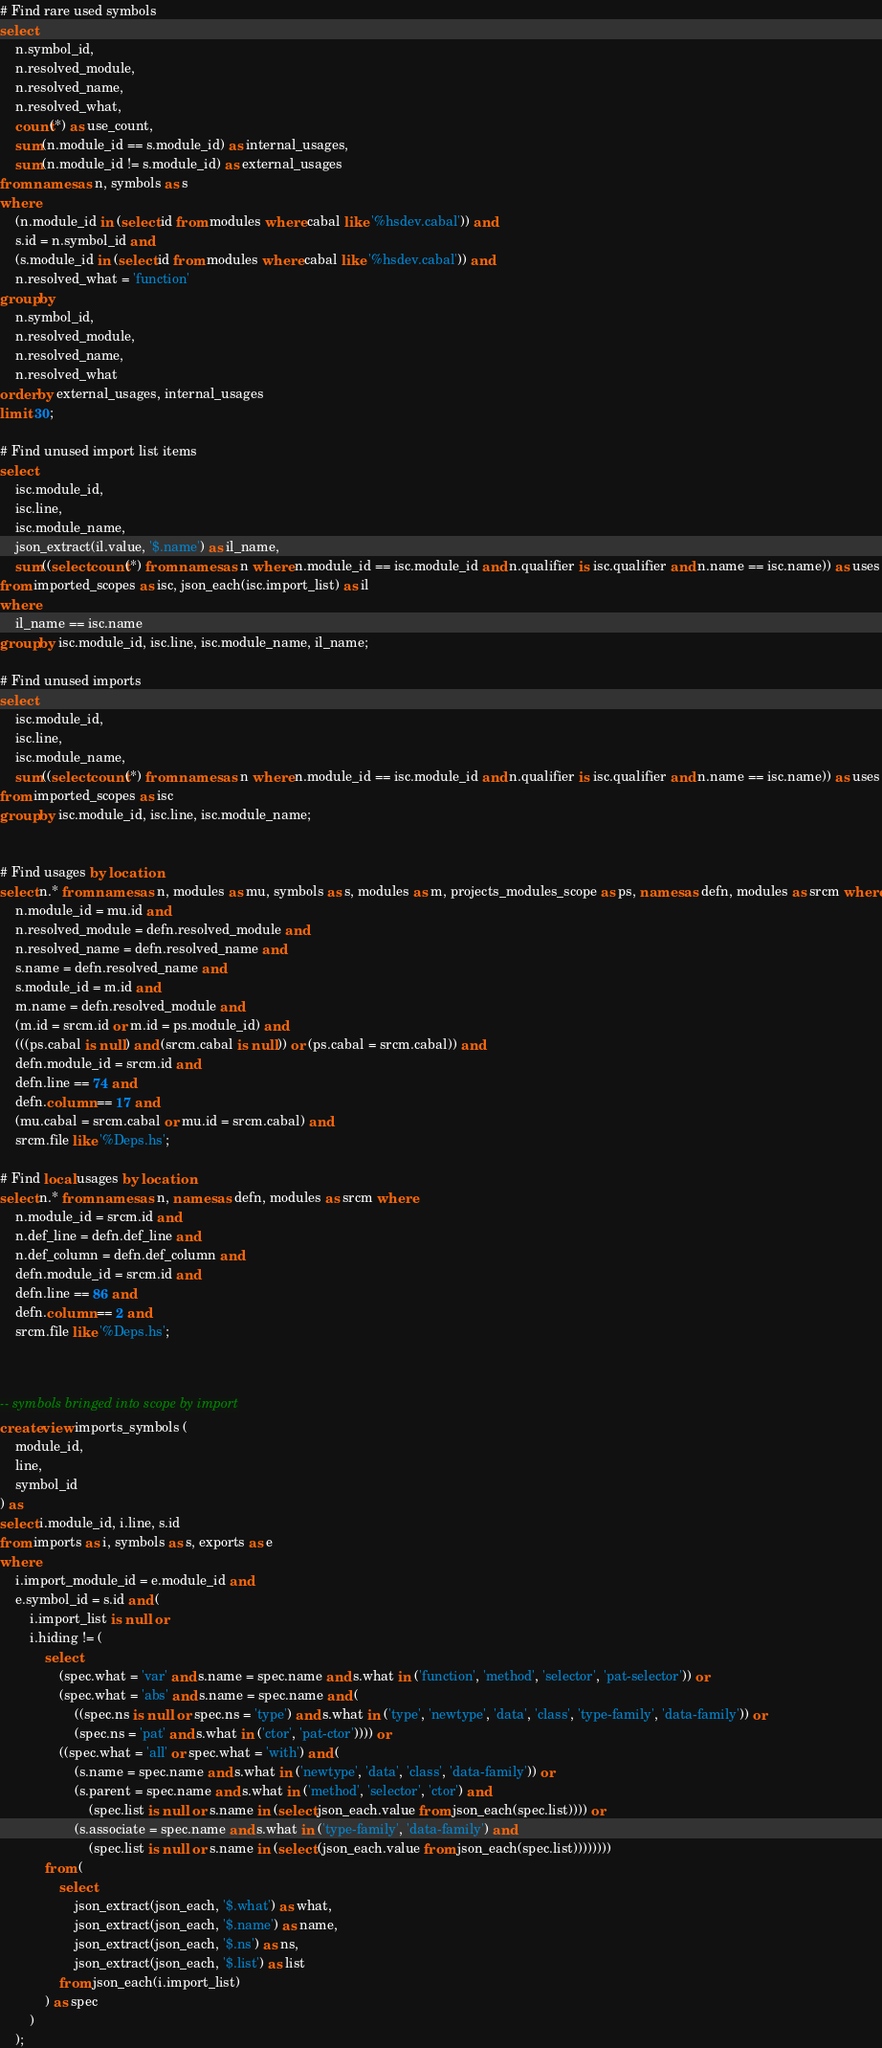Convert code to text. <code><loc_0><loc_0><loc_500><loc_500><_SQL_># Find rare used symbols
select
	n.symbol_id,
	n.resolved_module,
	n.resolved_name,
	n.resolved_what,
	count(*) as use_count,
	sum(n.module_id == s.module_id) as internal_usages,
	sum(n.module_id != s.module_id) as external_usages
from names as n, symbols as s
where
	(n.module_id in (select id from modules where cabal like '%hsdev.cabal')) and
	s.id = n.symbol_id and
	(s.module_id in (select id from modules where cabal like '%hsdev.cabal')) and
	n.resolved_what = 'function'
group by
	n.symbol_id,
	n.resolved_module,
	n.resolved_name,
	n.resolved_what
order by external_usages, internal_usages
limit 30;

# Find unused import list items
select
	isc.module_id,
	isc.line,
	isc.module_name,
	json_extract(il.value, '$.name') as il_name,
	sum((select count(*) from names as n where n.module_id == isc.module_id and n.qualifier is isc.qualifier and n.name == isc.name)) as uses
from imported_scopes as isc, json_each(isc.import_list) as il
where
	il_name == isc.name
group by isc.module_id, isc.line, isc.module_name, il_name;

# Find unused imports
select
	isc.module_id,
	isc.line,
	isc.module_name,
	sum((select count(*) from names as n where n.module_id == isc.module_id and n.qualifier is isc.qualifier and n.name == isc.name)) as uses
from imported_scopes as isc
group by isc.module_id, isc.line, isc.module_name;


# Find usages by location
select n.* from names as n, modules as mu, symbols as s, modules as m, projects_modules_scope as ps, names as defn, modules as srcm where
	n.module_id = mu.id and
	n.resolved_module = defn.resolved_module and
	n.resolved_name = defn.resolved_name and
	s.name = defn.resolved_name and
	s.module_id = m.id and
	m.name = defn.resolved_module and
	(m.id = srcm.id or m.id = ps.module_id) and
	(((ps.cabal is null) and (srcm.cabal is null)) or (ps.cabal = srcm.cabal)) and
	defn.module_id = srcm.id and
	defn.line == 74 and
	defn.column == 17 and
	(mu.cabal = srcm.cabal or mu.id = srcm.cabal) and
	srcm.file like '%Deps.hs';

# Find local usages by location
select n.* from names as n, names as defn, modules as srcm where
	n.module_id = srcm.id and
	n.def_line = defn.def_line and
	n.def_column = defn.def_column and
	defn.module_id = srcm.id and
	defn.line == 86 and
	defn.column == 2 and
	srcm.file like '%Deps.hs';



-- symbols bringed into scope by import
create view imports_symbols (
	module_id,
	line,
	symbol_id
) as
select i.module_id, i.line, s.id
from imports as i, symbols as s, exports as e
where
	i.import_module_id = e.module_id and
	e.symbol_id = s.id and (
		i.import_list is null or
		i.hiding != (
			select
				(spec.what = 'var' and s.name = spec.name and s.what in ('function', 'method', 'selector', 'pat-selector')) or
				(spec.what = 'abs' and s.name = spec.name and (
					((spec.ns is null or spec.ns = 'type') and s.what in ('type', 'newtype', 'data', 'class', 'type-family', 'data-family')) or
					(spec.ns = 'pat' and s.what in ('ctor', 'pat-ctor')))) or
				((spec.what = 'all' or spec.what = 'with') and (
					(s.name = spec.name and s.what in ('newtype', 'data', 'class', 'data-family')) or
					(s.parent = spec.name and s.what in ('method', 'selector', 'ctor') and
						(spec.list is null or s.name in (select json_each.value from json_each(spec.list)))) or
					(s.associate = spec.name and s.what in ('type-family', 'data-family') and
						(spec.list is null or s.name in (select (json_each.value from json_each(spec.list))))))))
			from (
				select
					json_extract(json_each, '$.what') as what,
					json_extract(json_each, '$.name') as name,
					json_extract(json_each, '$.ns') as ns,
					json_extract(json_each, '$.list') as list
				from json_each(i.import_list)
			) as spec
		)
	);
</code> 